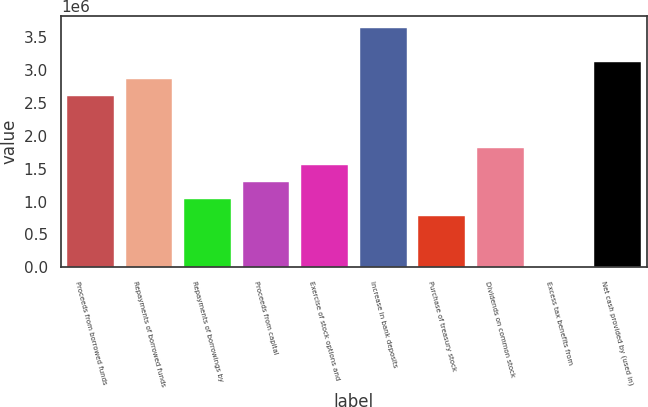Convert chart. <chart><loc_0><loc_0><loc_500><loc_500><bar_chart><fcel>Proceeds from borrowed funds<fcel>Repayments of borrowed funds<fcel>Repayments of borrowings by<fcel>Proceeds from capital<fcel>Exercise of stock options and<fcel>Increase in bank deposits<fcel>Purchase of treasury stock<fcel>Dividends on common stock<fcel>Excess tax benefits from<fcel>Net cash provided by (used in)<nl><fcel>2.59662e+06<fcel>2.85602e+06<fcel>1.0402e+06<fcel>1.2996e+06<fcel>1.55901e+06<fcel>3.63423e+06<fcel>780798<fcel>1.81841e+06<fcel>2590<fcel>3.11542e+06<nl></chart> 